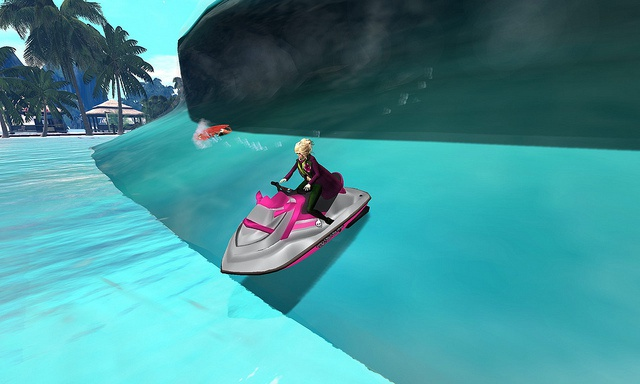Describe the objects in this image and their specific colors. I can see people in cyan, black, purple, khaki, and gray tones and surfboard in cyan, salmon, lightpink, brown, and darkgray tones in this image. 